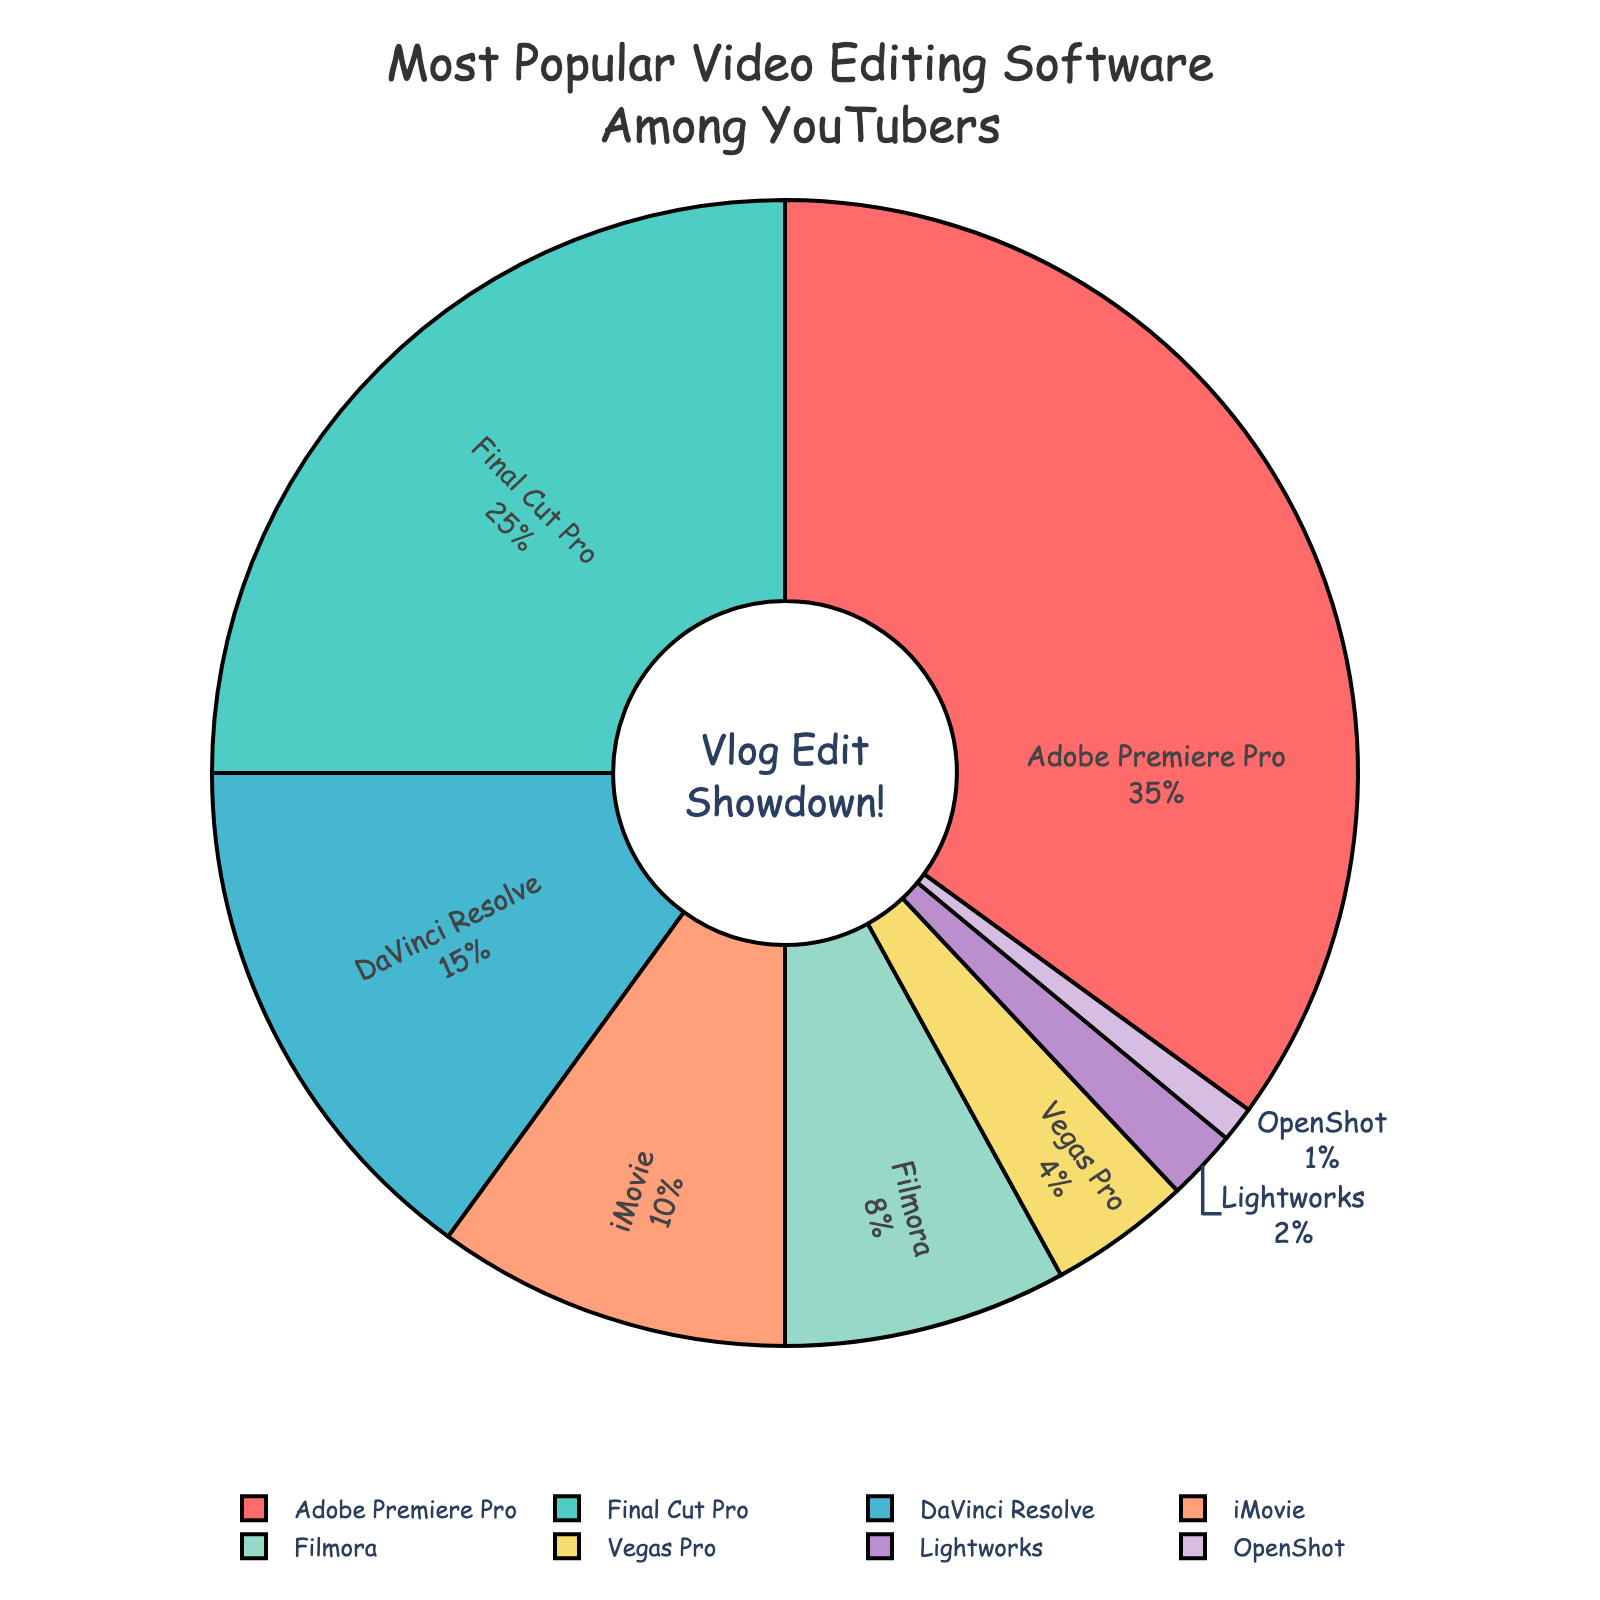Which software holds the largest market share among YouTubers? By looking at the pie chart, the largest segment represents Adobe Premiere Pro, labeled with 35%. So, Adobe Premiere Pro holds the largest market share among YouTubers.
Answer: Adobe Premiere Pro Which video editing software has the smallest percentage of users? The smallest segment in the pie chart is labeled as OpenShot with a 1% share.
Answer: OpenShot What is the combined percentage of users for Adobe Premiere Pro and Final Cut Pro? Adobe Premiere Pro holds 35% and Final Cut Pro holds 25%. Adding these together, 35% + 25% = 60%.
Answer: 60% How does the percentage of Final Cut Pro users compare to DaVinci Resolve users? Final Cut Pro is at 25% and DaVinci Resolve is at 15%. Since 25% is greater than 15%, Final Cut Pro has a larger user base than DaVinci Resolve.
Answer: Final Cut Pro has more users What is the percentage difference between Filmora and Vegas Pro? Filmora holds 8% and Vegas Pro holds 4%. The difference is 8% - 4% = 4%.
Answer: 4% How do iMovie and Filmora combined compare to Adobe Premiere Pro alone? iMovie holds 10% and Filmora holds 8%. Combined, they hold 10% + 8% = 18%. Adobe Premiere Pro alone holds 35%. Comparing 18% to 35%, Adobe Premiere Pro alone has a higher percentage.
Answer: Adobe Premiere Pro alone has more users What software shares an identical color in the pie chart? The pie chart segments are each unique in color. Therefore, no two segments share an identical color.
Answer: No software shares an identical color Name the software with a segment inside text orientation labeled radially inside the pie chart. The pie chart indicates that all software names are labeled with a radial inside text orientation, therefore, every software label fits this description.
Answer: All software labels 